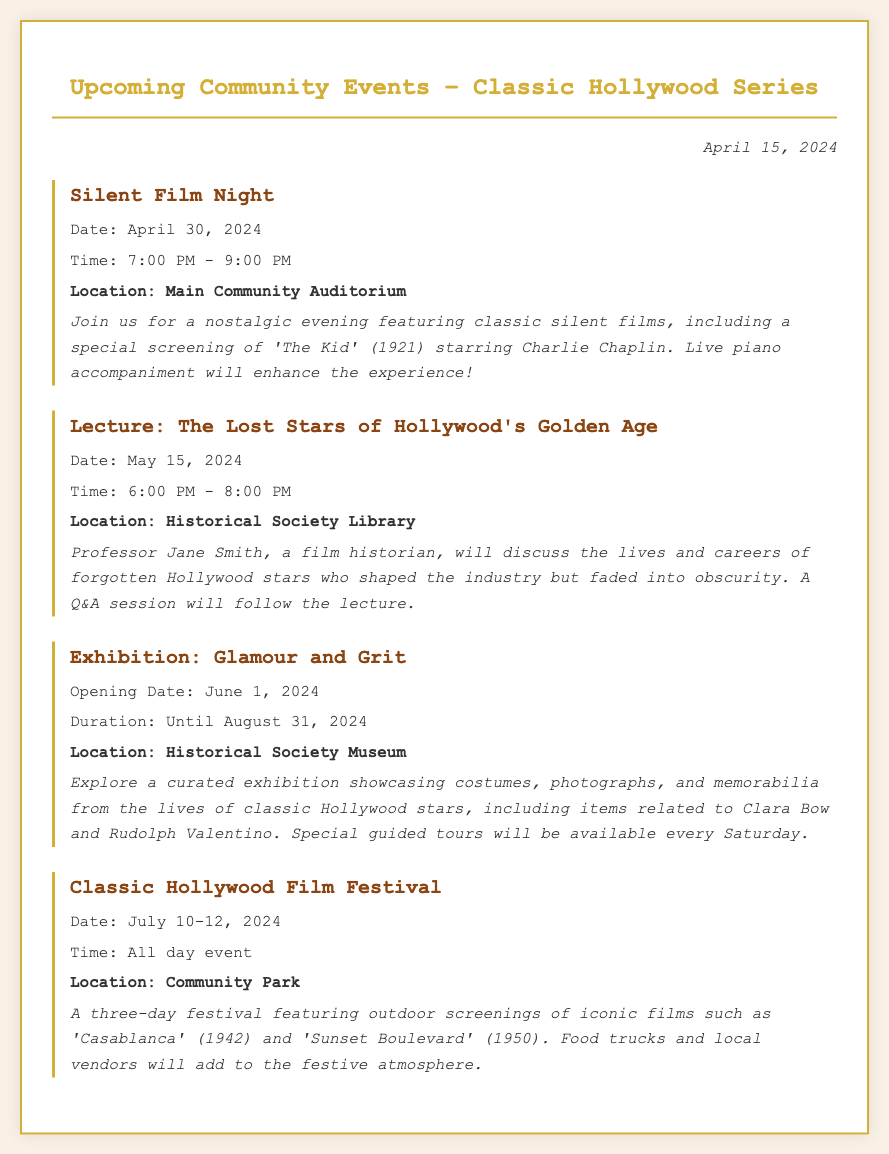What is the date of the Silent Film Night? The document specifies that the Silent Film Night is scheduled for April 30, 2024.
Answer: April 30, 2024 Who is the speaker for the Lecture on May 15, 2024? The document states that Professor Jane Smith will give the lecture regarding lost stars of Hollywood.
Answer: Professor Jane Smith What is featured in the Exhibition "Glamour and Grit"? The exhibition features costumes, photographs, and memorabilia from classic Hollywood stars, including items related to Clara Bow and Rudolph Valentino.
Answer: Costumes, photographs, and memorabilia What is the duration of the Exhibition? The document indicates that the exhibition runs from June 1, 2024, until August 31, 2024.
Answer: June 1, 2024 - August 31, 2024 How long will the Classic Hollywood Film Festival last? The document mentions that the film festival lasts for three days from July 10 to July 12, 2024.
Answer: Three days What type of films will be screened at the Classic Hollywood Film Festival? The memo highlights that the festival will feature iconic films such as 'Casablanca' and 'Sunset Boulevard'.
Answer: Iconic films Where will the Silent Film Night be held? The location for the Silent Film Night is listed as the Main Community Auditorium.
Answer: Main Community Auditorium What time does the Lecture start? According to the document, the Lecture begins at 6:00 PM on May 15, 2024.
Answer: 6:00 PM 